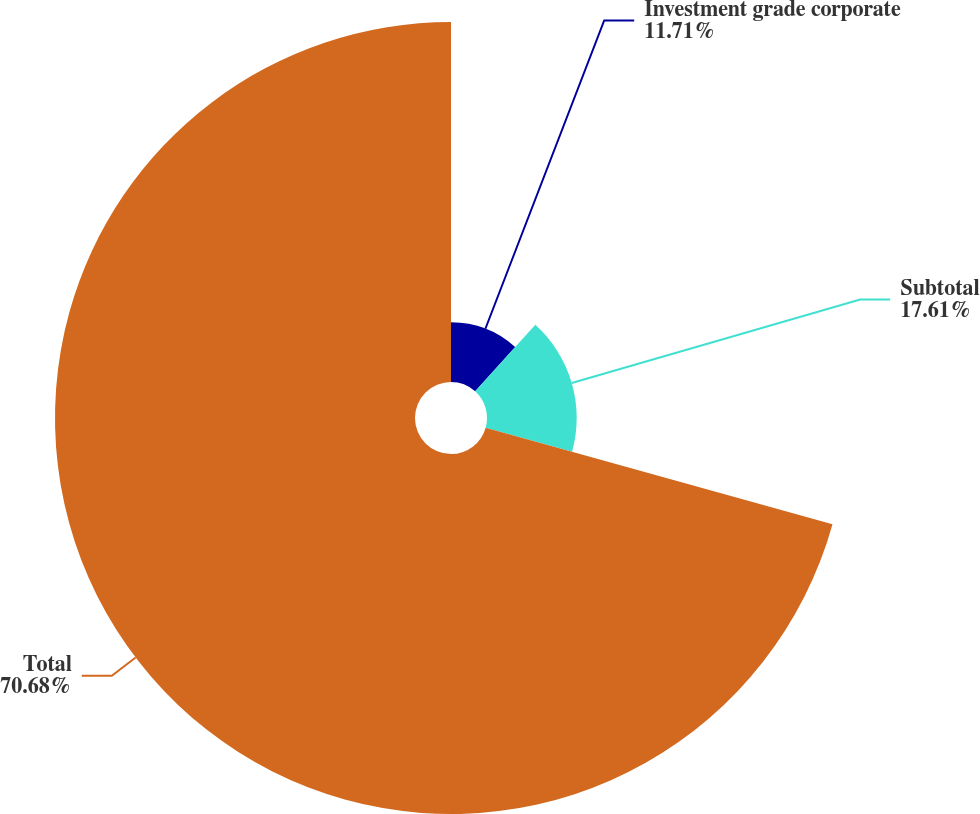Convert chart to OTSL. <chart><loc_0><loc_0><loc_500><loc_500><pie_chart><fcel>Investment grade corporate<fcel>Subtotal<fcel>Total<nl><fcel>11.71%<fcel>17.61%<fcel>70.68%<nl></chart> 